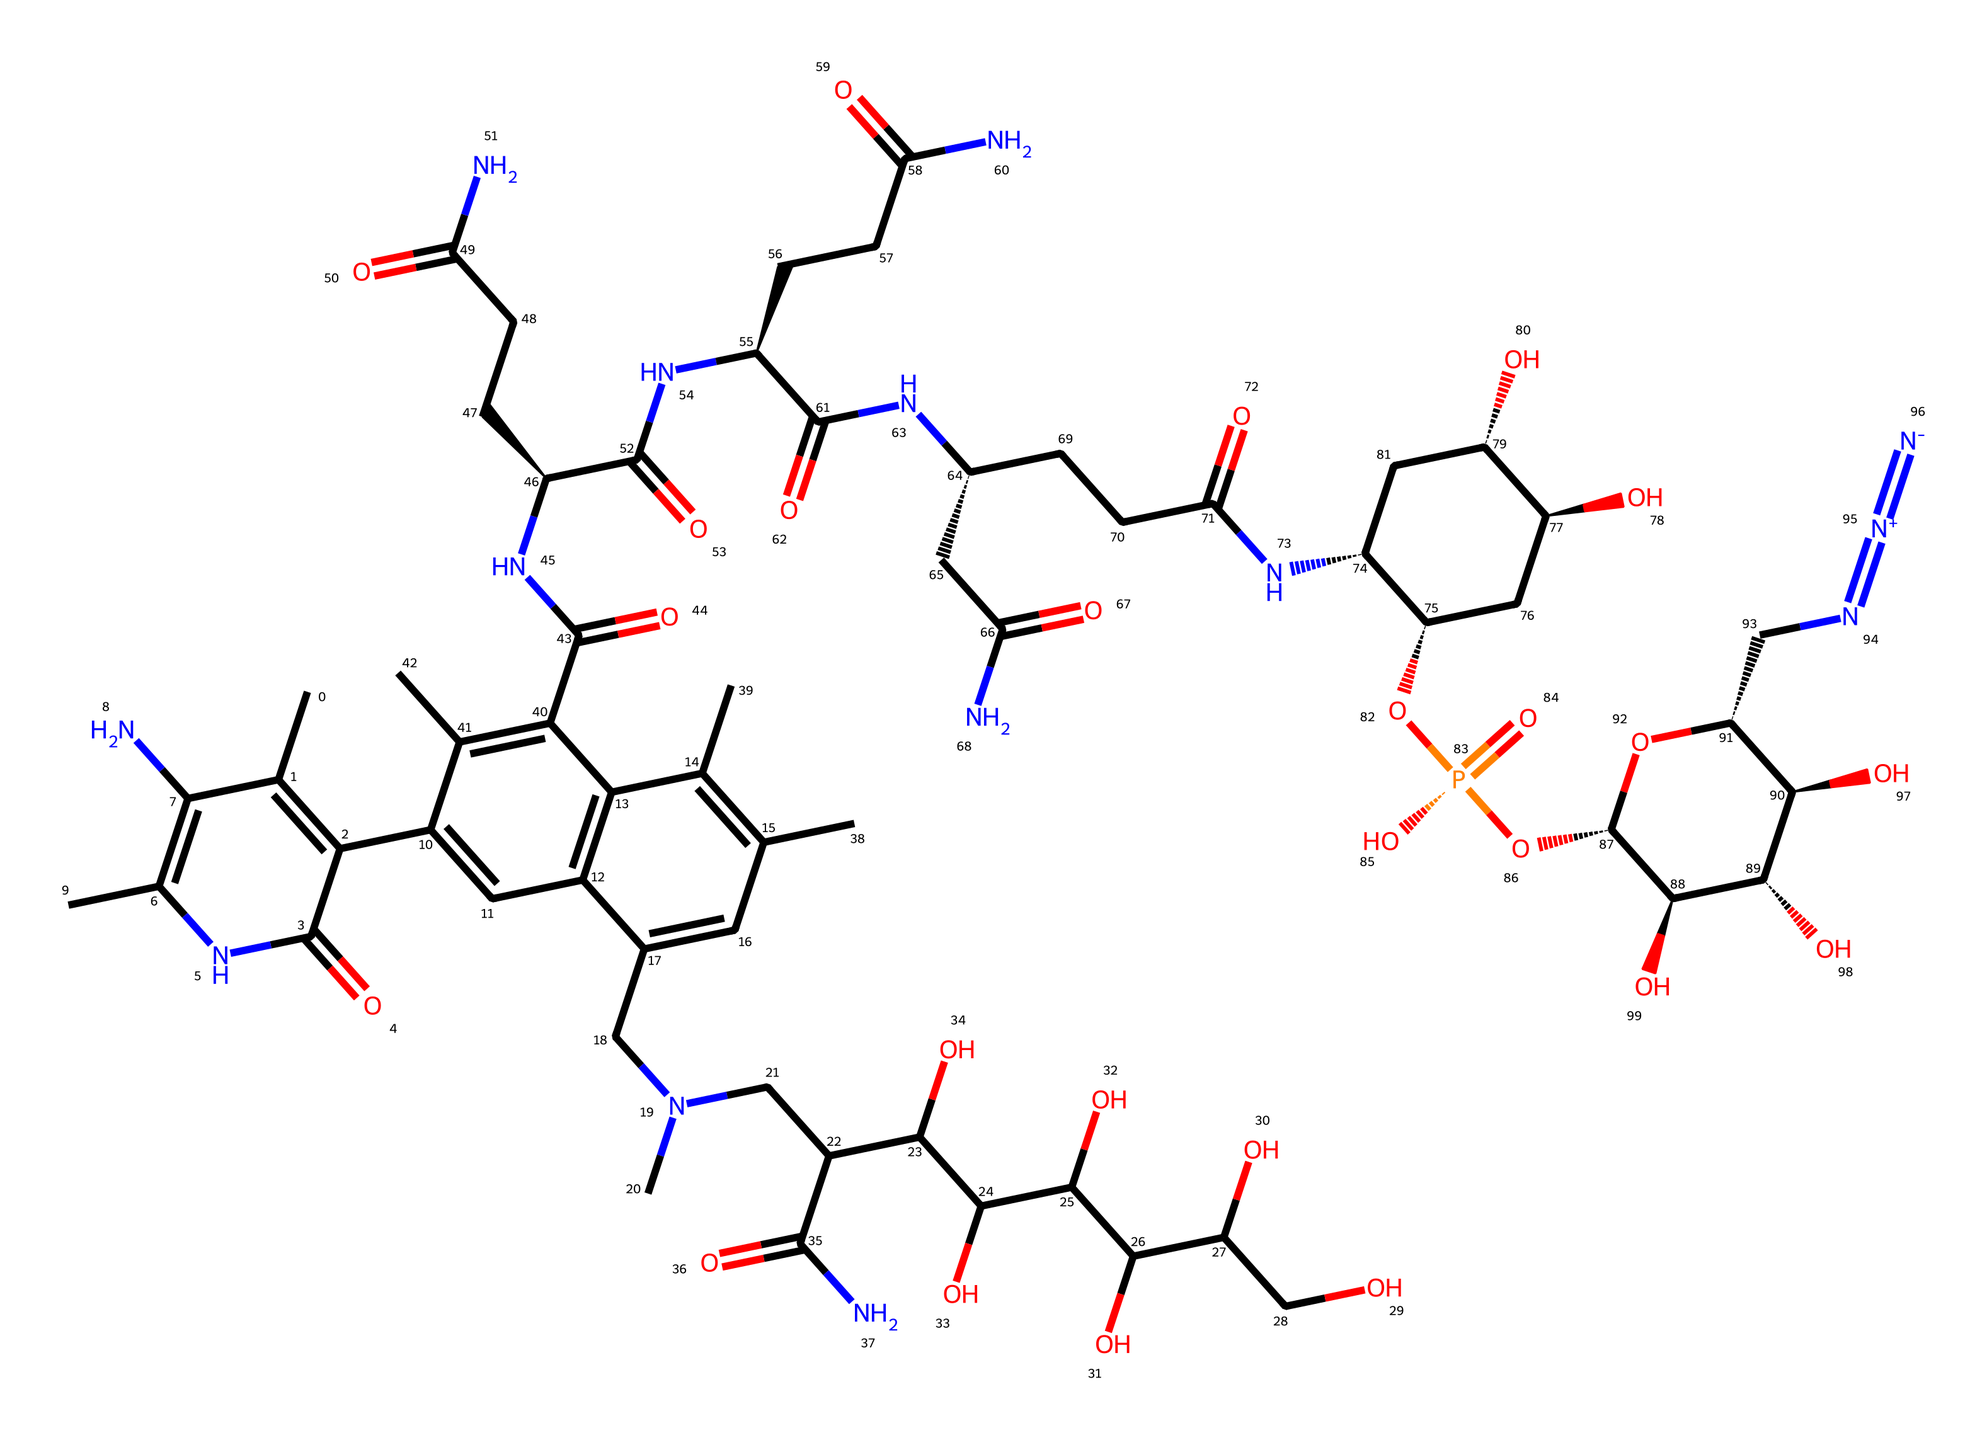How many carbon atoms are in vitamin B12? By analyzing the SMILES structure, we count the occurrences of carbon atoms (C) indicated in the chemical representation. The total count results in 30 carbon atoms.
Answer: 30 What is the primary nitrogen-containing group in vitamin B12? Observing the SMILES structure, we can identify the presence of amine groups, specifically the tertiary amine group that includes a nitrogen atom bonded to three carbon atoms, which is evident from the presence of the 'N' without any positive charge indications.
Answer: tertiary amine What is the total number of oxygen atoms present in this structure? By examining the SMILES representation, we identify all occurrences of oxygen atoms (O) in the chemical structure. By counting them, we determine there are 12 oxygen atoms.
Answer: 12 How does the structure of vitamin B12 correlate with its function in energy metabolism? The complex structure of vitamin B12, including cobalt at its center, participates in biochemical reactions related to energy production by facilitating the conversion of fatty acids and amino acids into energy. The presence of different functional groups also indicates its role in various enzymatic reactions essential for metabolism.
Answer: biochemical reactions What functional groups are represented in the vitamin B12 structure? Analyzing the SMILES notation, we can identify several functional groups such as carboxylic acids (evidenced by the 'C(=O)O'), amines (nitrogen-containing), and hydrocarbons which contribute to its overall function and solubility characteristics in biological systems.
Answer: carboxylic acids and amines Which part of vitamin B12 structure allows it to be water-soluble? The presence of multiple hydroxyl (–OH) groups within its structure contributes to the polarity of vitamin B12, making it soluble in water. These groups facilitate hydrogen bonding with water molecules, enhancing solubility.
Answer: hydroxyl groups 